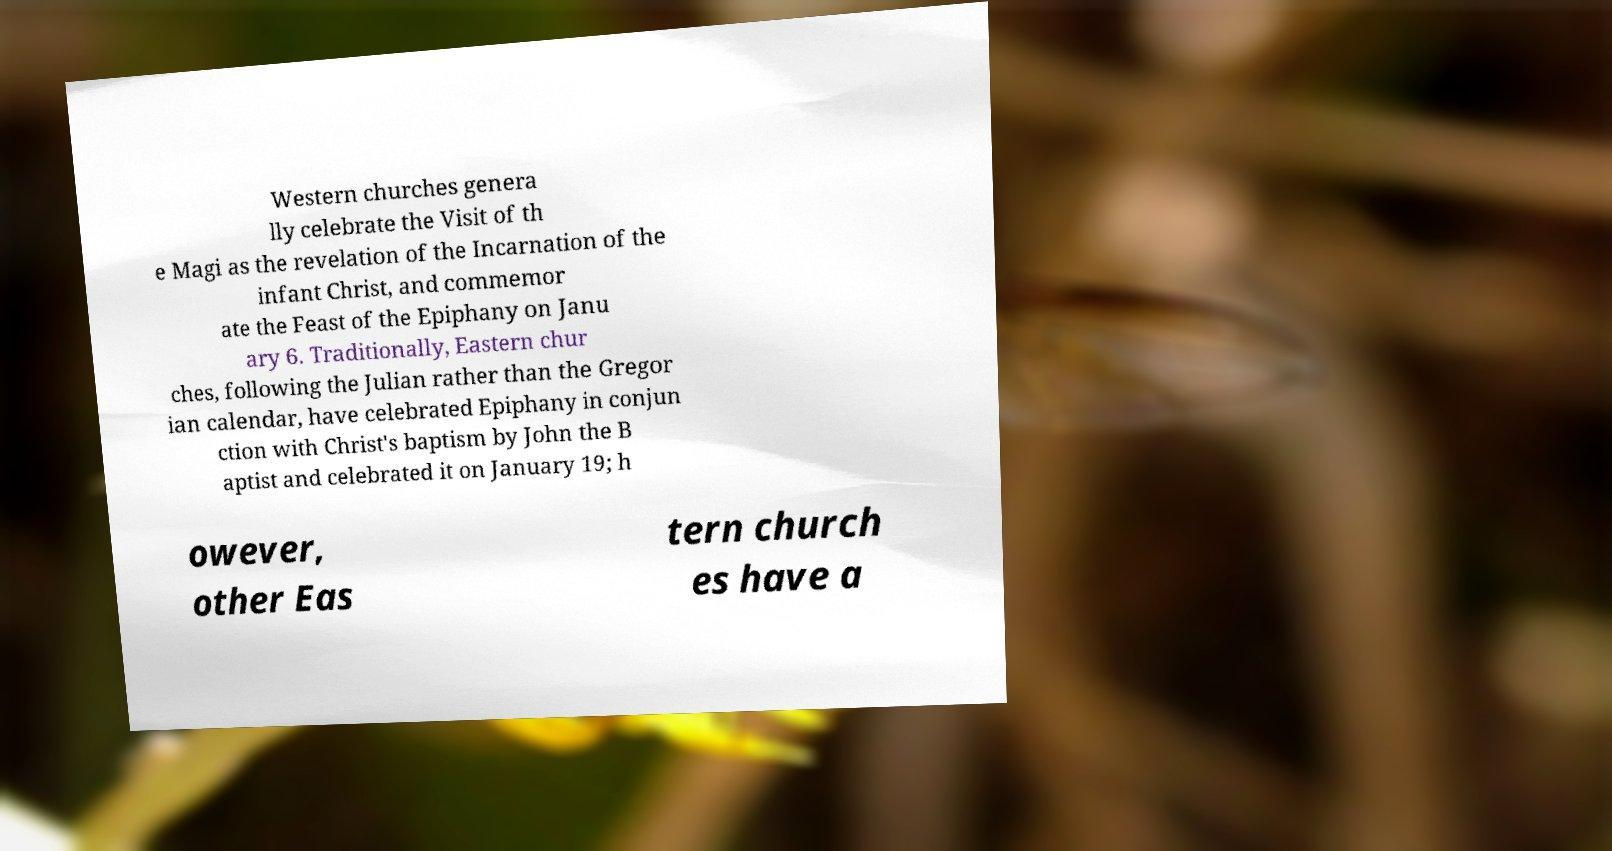There's text embedded in this image that I need extracted. Can you transcribe it verbatim? Western churches genera lly celebrate the Visit of th e Magi as the revelation of the Incarnation of the infant Christ, and commemor ate the Feast of the Epiphany on Janu ary 6. Traditionally, Eastern chur ches, following the Julian rather than the Gregor ian calendar, have celebrated Epiphany in conjun ction with Christ's baptism by John the B aptist and celebrated it on January 19; h owever, other Eas tern church es have a 